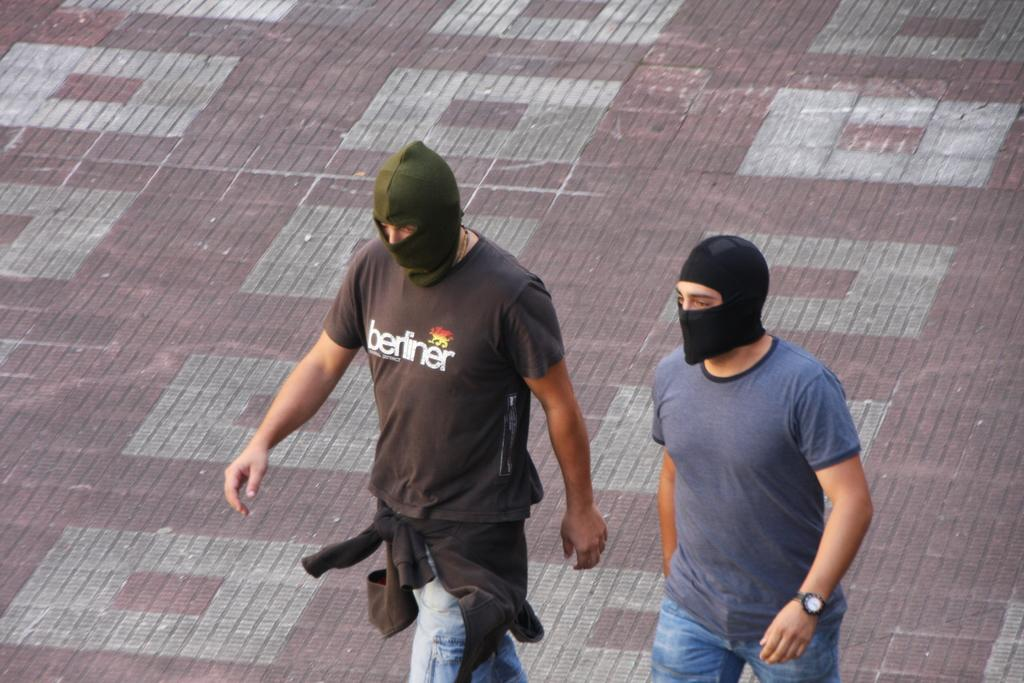How many people are in the image? There are two men in the image. What are the men wearing on their faces? The men are wearing masks. What are the men doing in the image? The men are walking on the floor. What type of pan can be seen being used by one of the men in the image? There is no pan present in the image; the men are wearing masks and walking on the floor. 